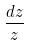<formula> <loc_0><loc_0><loc_500><loc_500>\frac { d z } { z }</formula> 